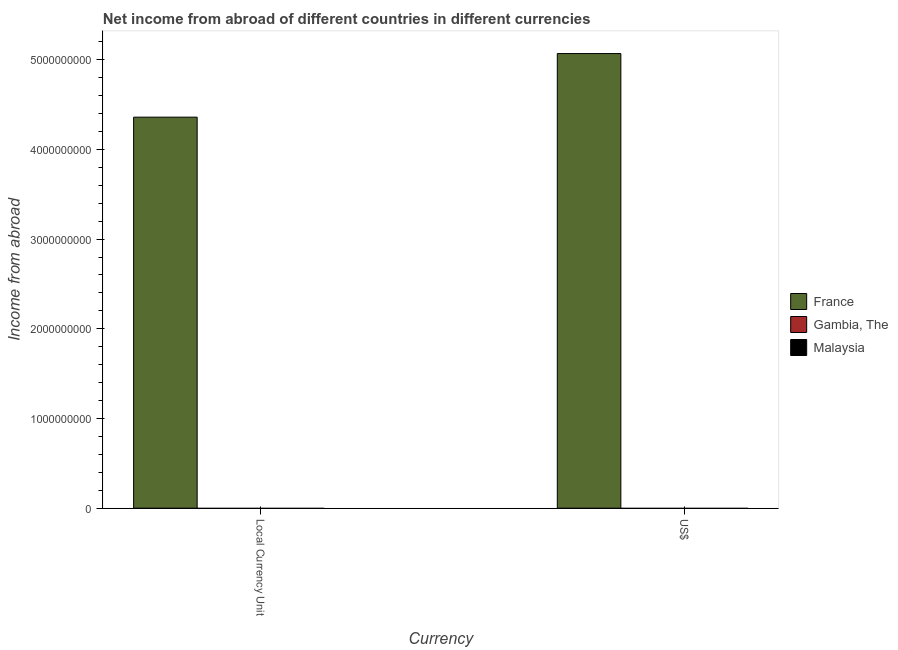How many different coloured bars are there?
Your answer should be very brief. 1. Are the number of bars per tick equal to the number of legend labels?
Make the answer very short. No. Are the number of bars on each tick of the X-axis equal?
Your answer should be compact. Yes. How many bars are there on the 2nd tick from the left?
Your answer should be very brief. 1. How many bars are there on the 1st tick from the right?
Keep it short and to the point. 1. What is the label of the 1st group of bars from the left?
Your answer should be compact. Local Currency Unit. What is the income from abroad in constant 2005 us$ in Malaysia?
Keep it short and to the point. 0. Across all countries, what is the maximum income from abroad in constant 2005 us$?
Offer a terse response. 4.36e+09. Across all countries, what is the minimum income from abroad in constant 2005 us$?
Keep it short and to the point. 0. What is the total income from abroad in constant 2005 us$ in the graph?
Provide a short and direct response. 4.36e+09. What is the difference between the income from abroad in constant 2005 us$ in Malaysia and the income from abroad in us$ in Gambia, The?
Your response must be concise. 0. What is the average income from abroad in us$ per country?
Your answer should be compact. 1.69e+09. What is the difference between the income from abroad in constant 2005 us$ and income from abroad in us$ in France?
Your answer should be very brief. -7.09e+08. How many bars are there?
Offer a terse response. 2. How many countries are there in the graph?
Offer a very short reply. 3. What is the difference between two consecutive major ticks on the Y-axis?
Give a very brief answer. 1.00e+09. Are the values on the major ticks of Y-axis written in scientific E-notation?
Provide a succinct answer. No. Where does the legend appear in the graph?
Your answer should be very brief. Center right. How are the legend labels stacked?
Your answer should be very brief. Vertical. What is the title of the graph?
Your answer should be very brief. Net income from abroad of different countries in different currencies. What is the label or title of the X-axis?
Provide a short and direct response. Currency. What is the label or title of the Y-axis?
Your response must be concise. Income from abroad. What is the Income from abroad in France in Local Currency Unit?
Ensure brevity in your answer.  4.36e+09. What is the Income from abroad of Gambia, The in Local Currency Unit?
Your response must be concise. 0. What is the Income from abroad of France in US$?
Your response must be concise. 5.07e+09. What is the Income from abroad of Gambia, The in US$?
Make the answer very short. 0. What is the Income from abroad in Malaysia in US$?
Give a very brief answer. 0. Across all Currency, what is the maximum Income from abroad in France?
Give a very brief answer. 5.07e+09. Across all Currency, what is the minimum Income from abroad in France?
Your answer should be very brief. 4.36e+09. What is the total Income from abroad of France in the graph?
Provide a succinct answer. 9.43e+09. What is the total Income from abroad in Gambia, The in the graph?
Your response must be concise. 0. What is the total Income from abroad in Malaysia in the graph?
Keep it short and to the point. 0. What is the difference between the Income from abroad in France in Local Currency Unit and that in US$?
Ensure brevity in your answer.  -7.09e+08. What is the average Income from abroad of France per Currency?
Your response must be concise. 4.71e+09. What is the average Income from abroad of Malaysia per Currency?
Ensure brevity in your answer.  0. What is the ratio of the Income from abroad of France in Local Currency Unit to that in US$?
Your answer should be compact. 0.86. What is the difference between the highest and the second highest Income from abroad of France?
Provide a short and direct response. 7.09e+08. What is the difference between the highest and the lowest Income from abroad of France?
Give a very brief answer. 7.09e+08. 